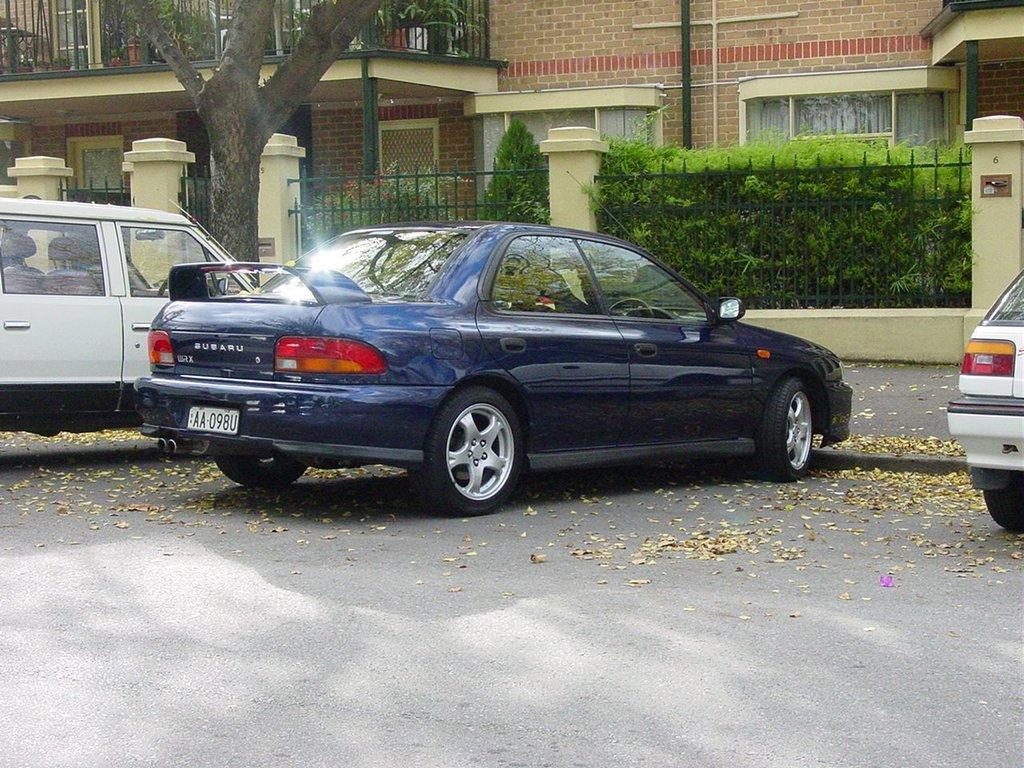How would you summarize this image in a sentence or two? In this image we can see cars on the road. In the background of the image there is a house, metal fencing, plants, trees. 